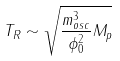Convert formula to latex. <formula><loc_0><loc_0><loc_500><loc_500>T _ { R } \sim \sqrt { \frac { m _ { o s c } ^ { 3 } } { \phi _ { 0 } ^ { 2 } } M _ { p } }</formula> 